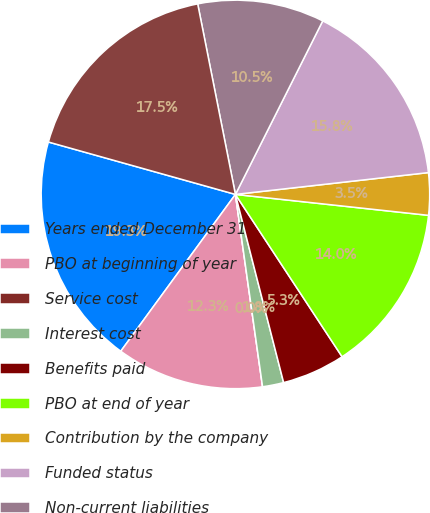Convert chart to OTSL. <chart><loc_0><loc_0><loc_500><loc_500><pie_chart><fcel>Years ended December 31<fcel>PBO at beginning of year<fcel>Service cost<fcel>Interest cost<fcel>Benefits paid<fcel>PBO at end of year<fcel>Contribution by the company<fcel>Funded status<fcel>Non-current liabilities<fcel>Net pension liability at end<nl><fcel>19.3%<fcel>12.28%<fcel>0.0%<fcel>1.76%<fcel>5.26%<fcel>14.03%<fcel>3.51%<fcel>15.79%<fcel>10.53%<fcel>17.54%<nl></chart> 